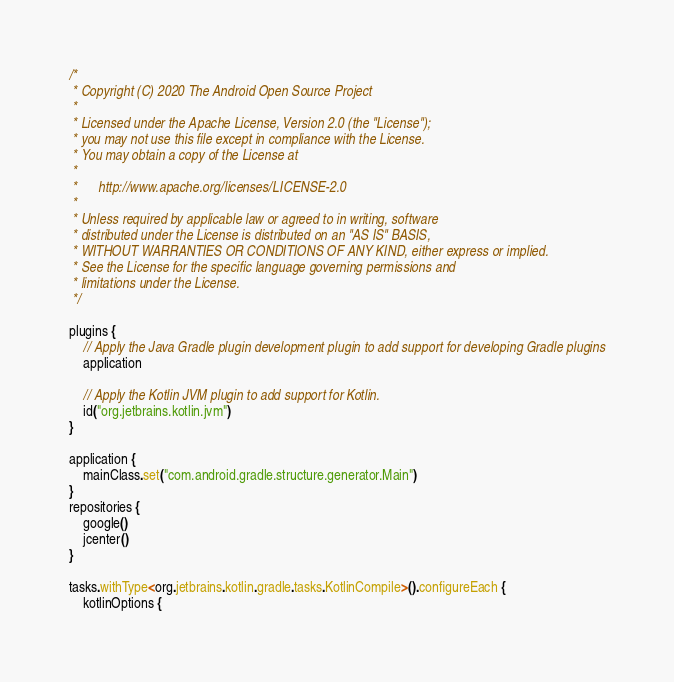Convert code to text. <code><loc_0><loc_0><loc_500><loc_500><_Kotlin_>/*
 * Copyright (C) 2020 The Android Open Source Project
 *
 * Licensed under the Apache License, Version 2.0 (the "License");
 * you may not use this file except in compliance with the License.
 * You may obtain a copy of the License at
 *
 *      http://www.apache.org/licenses/LICENSE-2.0
 *
 * Unless required by applicable law or agreed to in writing, software
 * distributed under the License is distributed on an "AS IS" BASIS,
 * WITHOUT WARRANTIES OR CONDITIONS OF ANY KIND, either express or implied.
 * See the License for the specific language governing permissions and
 * limitations under the License.
 */

plugins {
    // Apply the Java Gradle plugin development plugin to add support for developing Gradle plugins
    application

    // Apply the Kotlin JVM plugin to add support for Kotlin.
    id("org.jetbrains.kotlin.jvm")
}

application {
    mainClass.set("com.android.gradle.structure.generator.Main")
}
repositories {
    google()
    jcenter()
}

tasks.withType<org.jetbrains.kotlin.gradle.tasks.KotlinCompile>().configureEach {
    kotlinOptions {</code> 